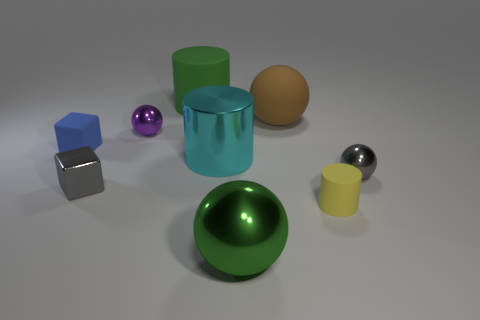Is the color of the big matte cylinder the same as the large metal sphere? The color of the large matte cylinder and the large metal sphere both exhibit a shade of green. However, there are nuances in their appearance; the cylinder has a matte finish, while the sphere has a reflective metallic finish, which influences the perception of their colors under light. 